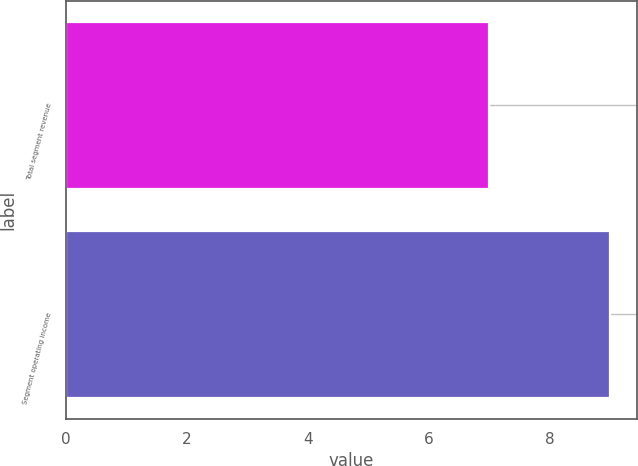Convert chart to OTSL. <chart><loc_0><loc_0><loc_500><loc_500><bar_chart><fcel>Total segment revenue<fcel>Segment operating income<nl><fcel>7<fcel>9<nl></chart> 